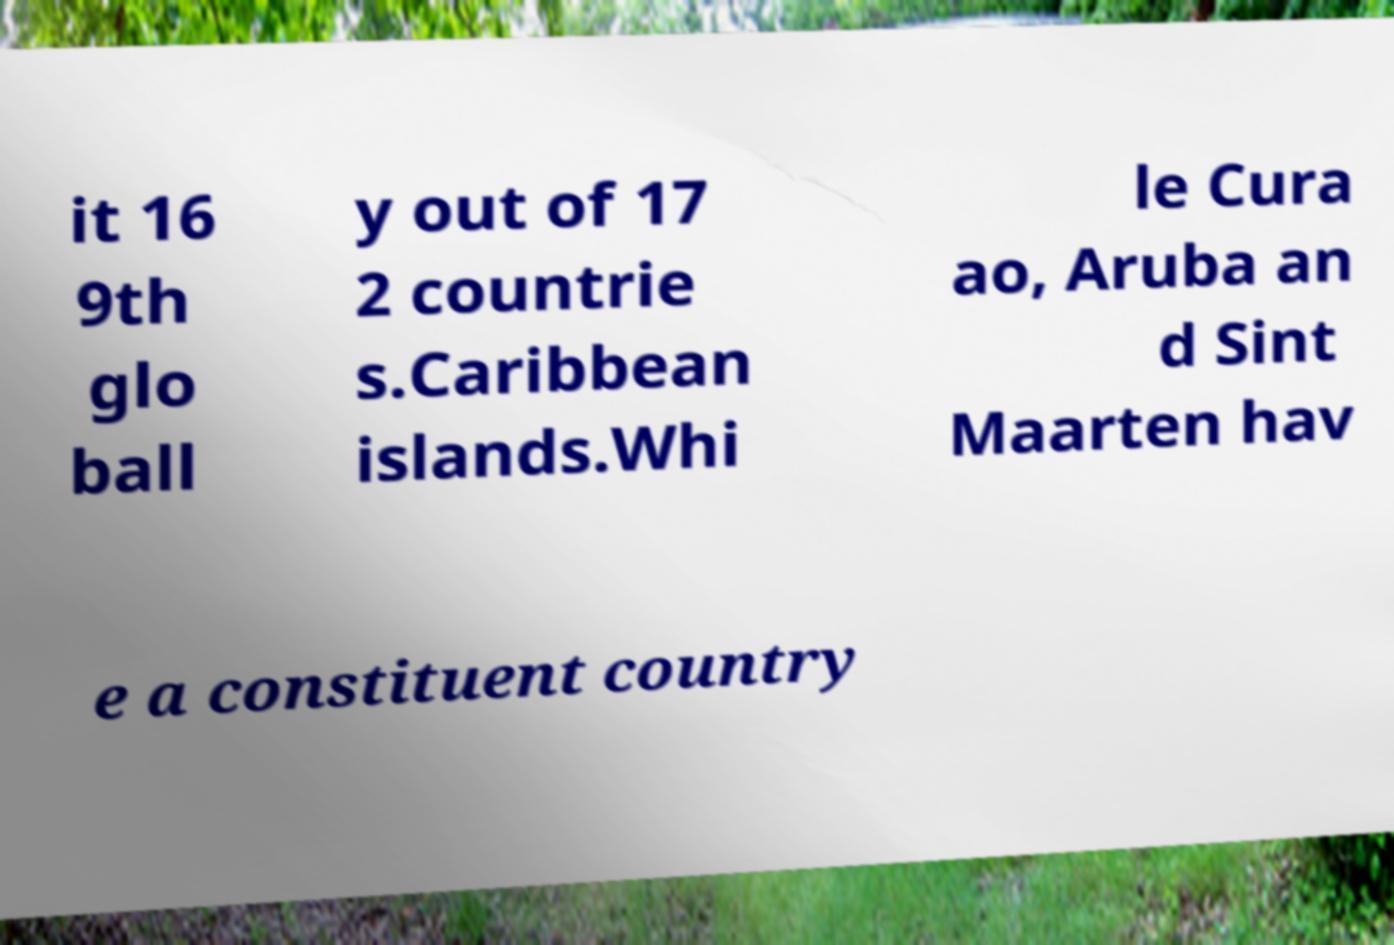There's text embedded in this image that I need extracted. Can you transcribe it verbatim? it 16 9th glo ball y out of 17 2 countrie s.Caribbean islands.Whi le Cura ao, Aruba an d Sint Maarten hav e a constituent country 